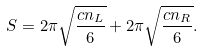<formula> <loc_0><loc_0><loc_500><loc_500>S = 2 \pi \sqrt { \frac { c n _ { L } } { 6 } } + 2 \pi \sqrt { \frac { c n _ { R } } { 6 } } .</formula> 